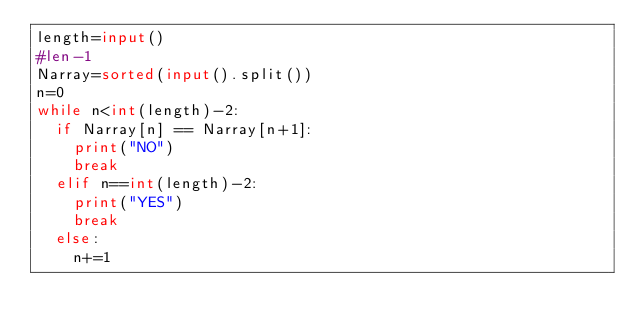Convert code to text. <code><loc_0><loc_0><loc_500><loc_500><_Python_>length=input()
#len-1
Narray=sorted(input().split())
n=0
while n<int(length)-2:
	if Narray[n] == Narray[n+1]:
		print("NO")
		break
	elif n==int(length)-2:
		print("YES")
		break
	else:
		n+=1
    	</code> 